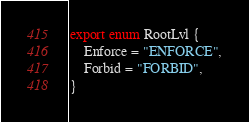Convert code to text. <code><loc_0><loc_0><loc_500><loc_500><_TypeScript_>export enum RootLvl {
    Enforce = "ENFORCE",
    Forbid = "FORBID",
}
</code> 